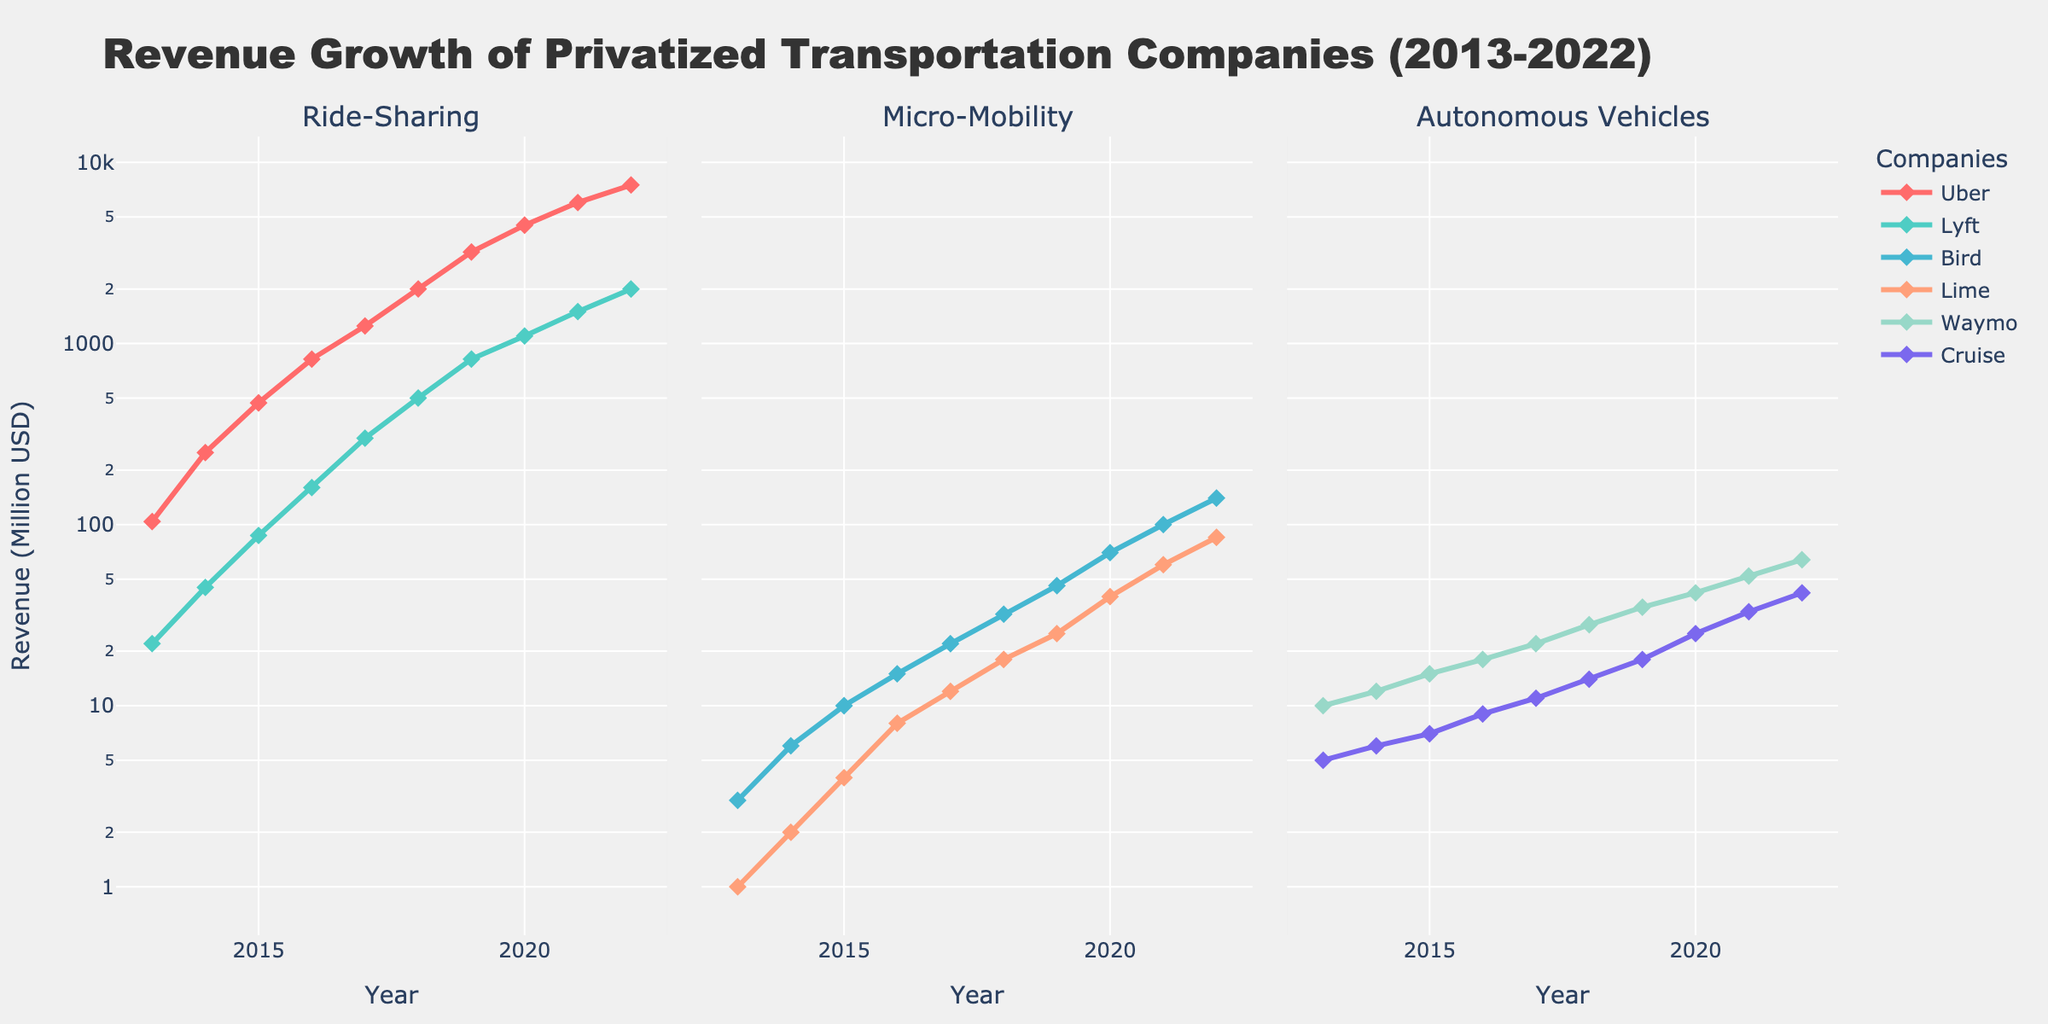What is the title of the figure? The title is usually located at the top of the figure. It provides an overview of what the figure is about. By reading the title, you can know the main focus of the subplot.
Answer: Revenue Growth of Privatized Transportation Companies (2013-2022) Which company had the highest revenue in 2022 among ride-sharing services? To find this, look at the Ride-Sharing subplot and compare the 2022 data points for Uber and Lyft.
Answer: Uber How many types of services are compared in the figure? Count the individual subplots, each representing a type of service.
Answer: Three What is the y-axis scale used in the figure? Check the y-axis label and note the type of scale. It should indicate if it is a linear or logarithmic scale.
Answer: Logarithmic What is the revenue of Lime in 2020? Look at the data point for Lime in the Micro-Mobility subplot for the year 2020.
Answer: 40 Million USD What is the average revenue growth from 2013 to 2022 for Waymo? First, note the revenue values for Waymo in 2013 and 2022 from the Autonomous Vehicles subplot. Then calculate the average growth over these years.
Answer: (10 + 12 + 15 + 18 + 22 + 28 + 35 + 42 + 52 + 64) / 10 = 29.8 Million USD Which type of service has the least revenue growth rate from 2013 to 2022? Explain your reasoning. Calculate the compound annual growth rate (CAGR) for each service to determine the one with the slowest relative growth. The revenue in 2013 and 2022 and the formula for CAGR ([(Ending Value/Beginning Value)^(1/Number of Periods)] - 1) can be used.
Answer: Micro-Mobility Between Bird and Lime, which company shows a faster growth rate between 2018 and 2022? Calculate the growth percentage for both Bird and Lime across 2018 and 2022. Bird: ((140 - 32) / 32) x 100 = 337.5%, Lime: ((85 - 18) / 18) x 100 = 372.22%
Answer: Lime In which year did Cruise's revenue first exceed 10 million USD? Check the Autonomous Vehicles subplot and find the earliest year where Cruise's data point is greater than 10 million USD.
Answer: 2016 